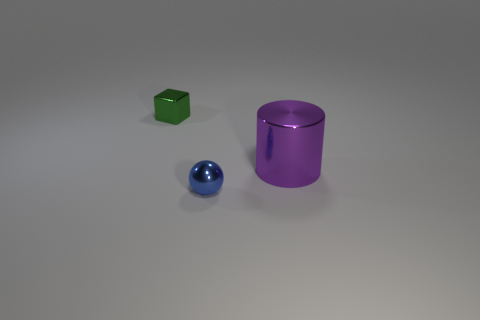Add 3 spheres. How many objects exist? 6 Subtract all balls. How many objects are left? 2 Add 1 green objects. How many green objects are left? 2 Add 1 small blue rubber objects. How many small blue rubber objects exist? 1 Subtract 1 blue spheres. How many objects are left? 2 Subtract all red rubber cylinders. Subtract all small green blocks. How many objects are left? 2 